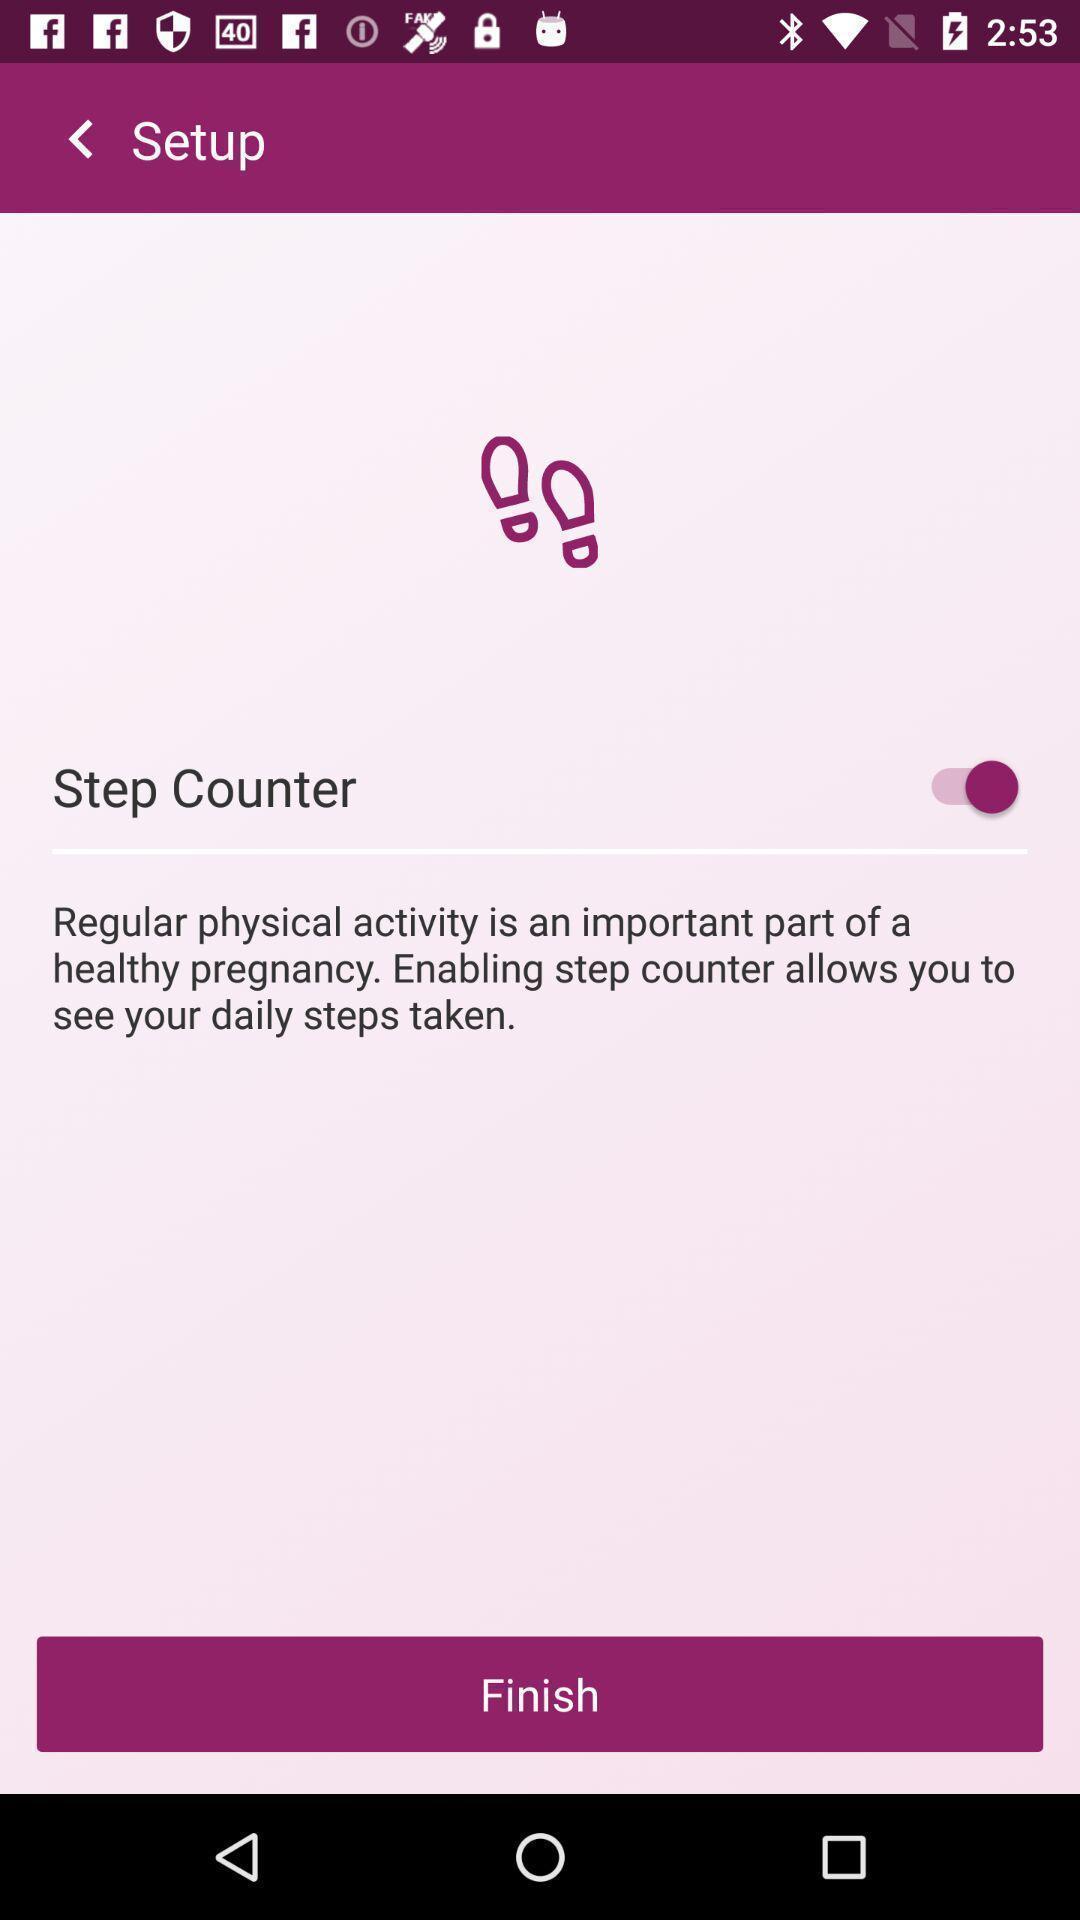Explain the elements present in this screenshot. Setup page in a health app. 